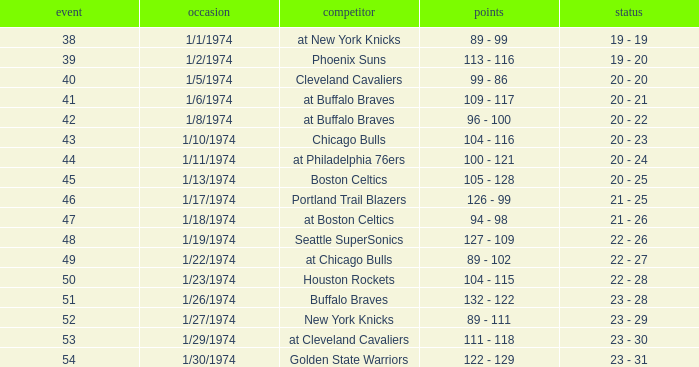What was the record after game 51 on 1/27/1974? 23 - 29. 